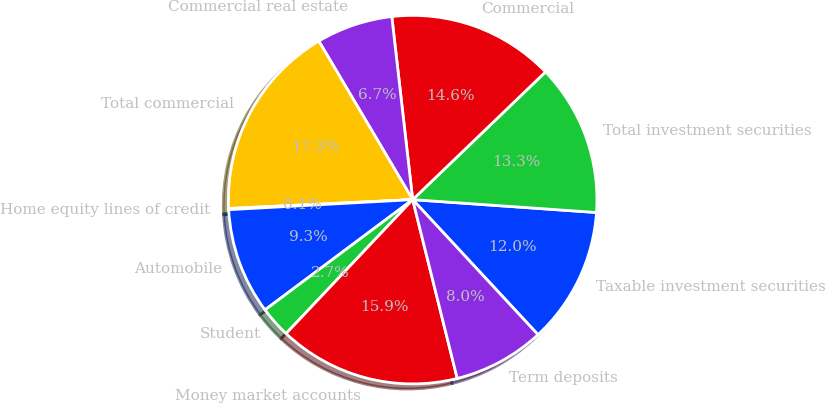Convert chart. <chart><loc_0><loc_0><loc_500><loc_500><pie_chart><fcel>Taxable investment securities<fcel>Total investment securities<fcel>Commercial<fcel>Commercial real estate<fcel>Total commercial<fcel>Home equity lines of credit<fcel>Automobile<fcel>Student<fcel>Money market accounts<fcel>Term deposits<nl><fcel>11.98%<fcel>13.3%<fcel>14.62%<fcel>6.7%<fcel>17.26%<fcel>0.1%<fcel>9.34%<fcel>2.74%<fcel>15.94%<fcel>8.02%<nl></chart> 